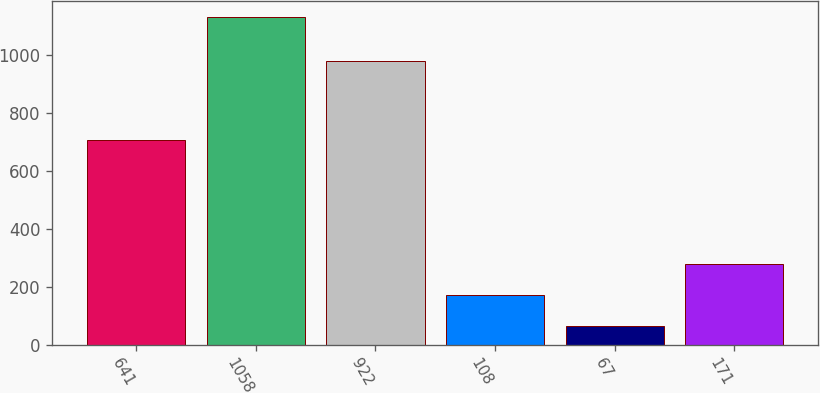Convert chart. <chart><loc_0><loc_0><loc_500><loc_500><bar_chart><fcel>641<fcel>1058<fcel>922<fcel>108<fcel>67<fcel>171<nl><fcel>706<fcel>1129<fcel>978<fcel>170.5<fcel>64<fcel>277<nl></chart> 